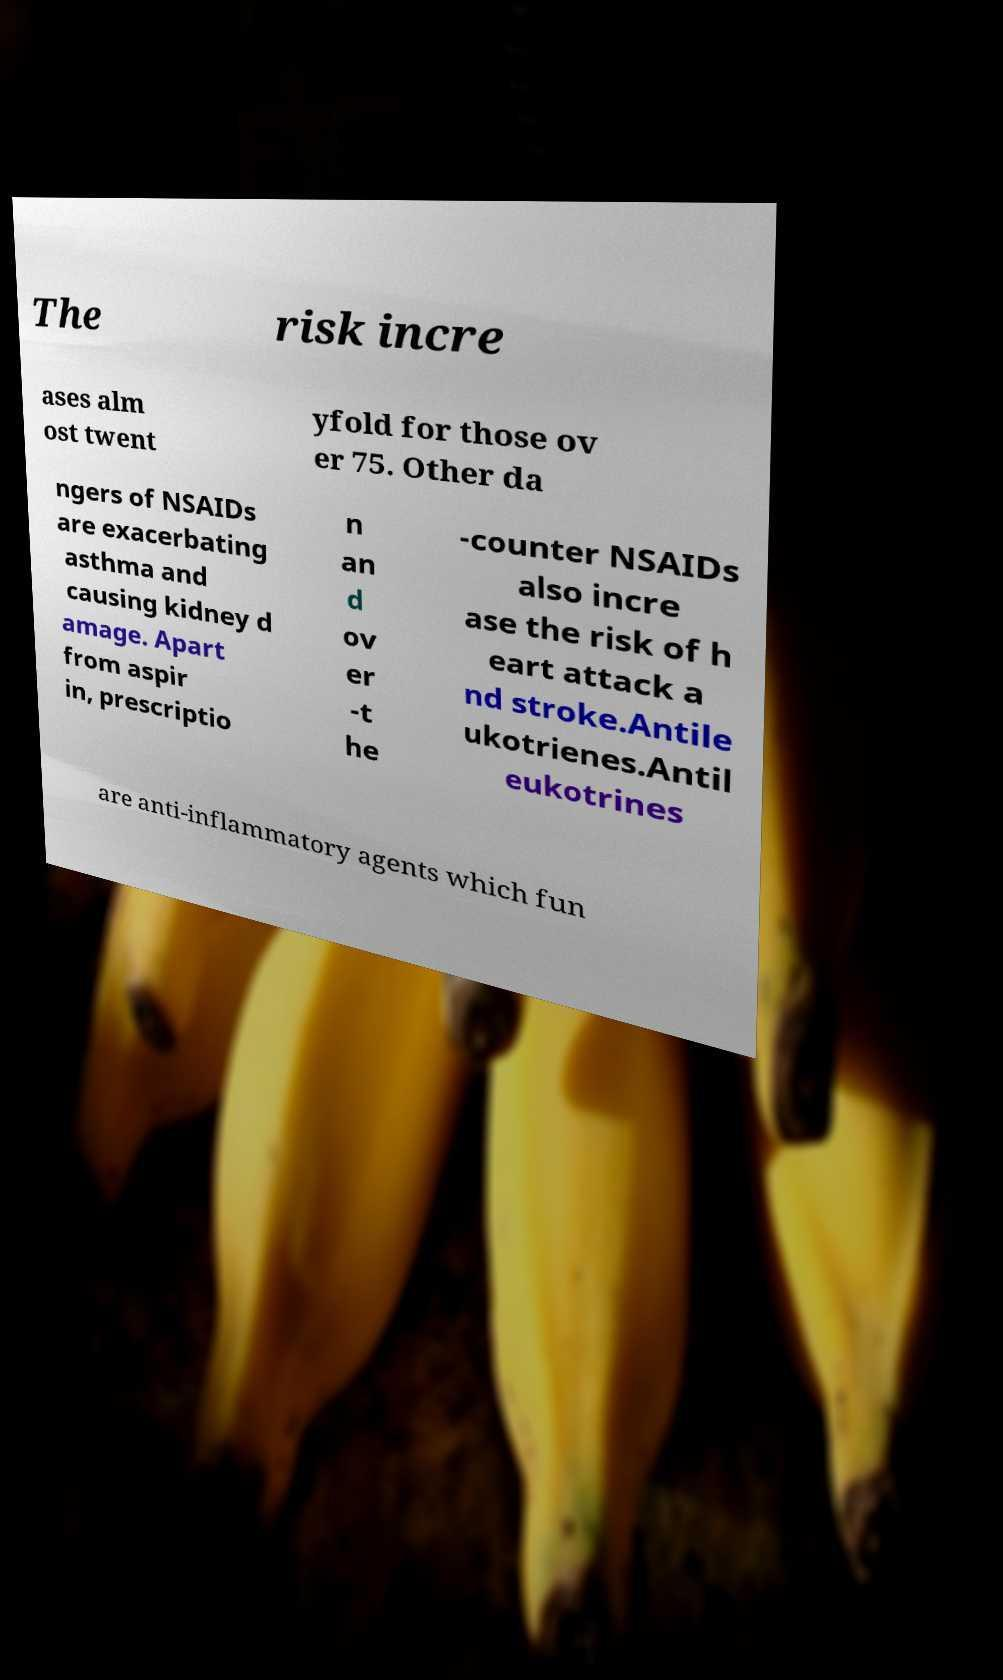Can you read and provide the text displayed in the image?This photo seems to have some interesting text. Can you extract and type it out for me? The risk incre ases alm ost twent yfold for those ov er 75. Other da ngers of NSAIDs are exacerbating asthma and causing kidney d amage. Apart from aspir in, prescriptio n an d ov er -t he -counter NSAIDs also incre ase the risk of h eart attack a nd stroke.Antile ukotrienes.Antil eukotrines are anti-inflammatory agents which fun 